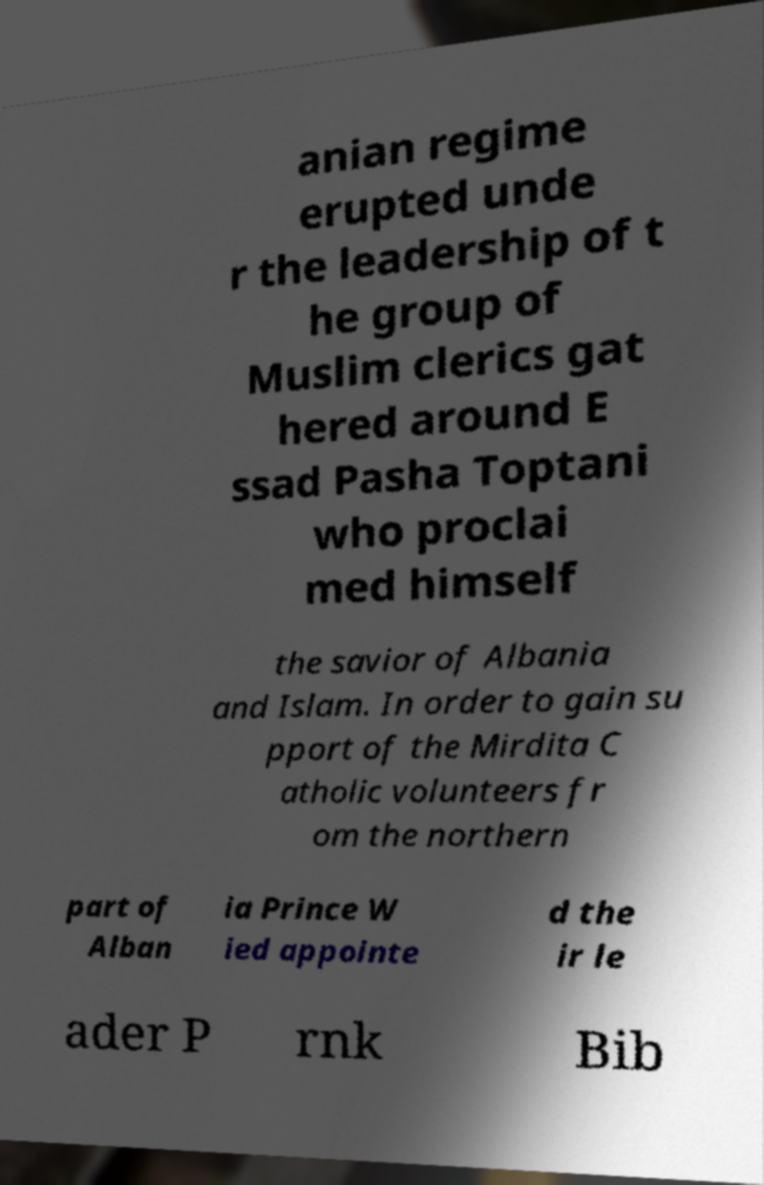There's text embedded in this image that I need extracted. Can you transcribe it verbatim? anian regime erupted unde r the leadership of t he group of Muslim clerics gat hered around E ssad Pasha Toptani who proclai med himself the savior of Albania and Islam. In order to gain su pport of the Mirdita C atholic volunteers fr om the northern part of Alban ia Prince W ied appointe d the ir le ader P rnk Bib 